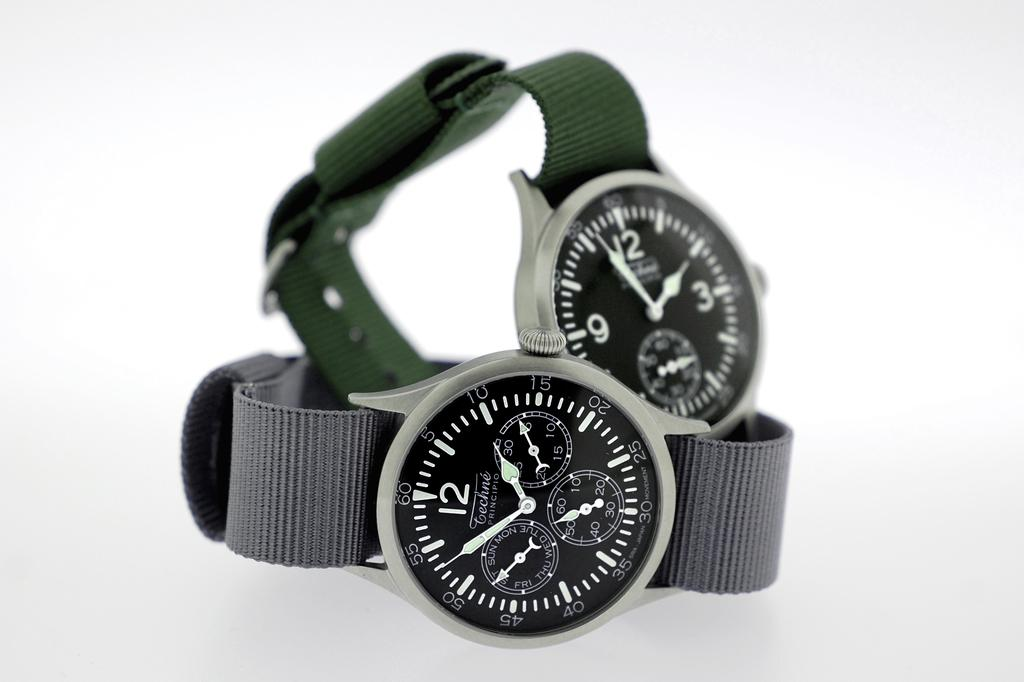<image>
Provide a brief description of the given image. Watches that are both set to two o clock and 3 o clock 